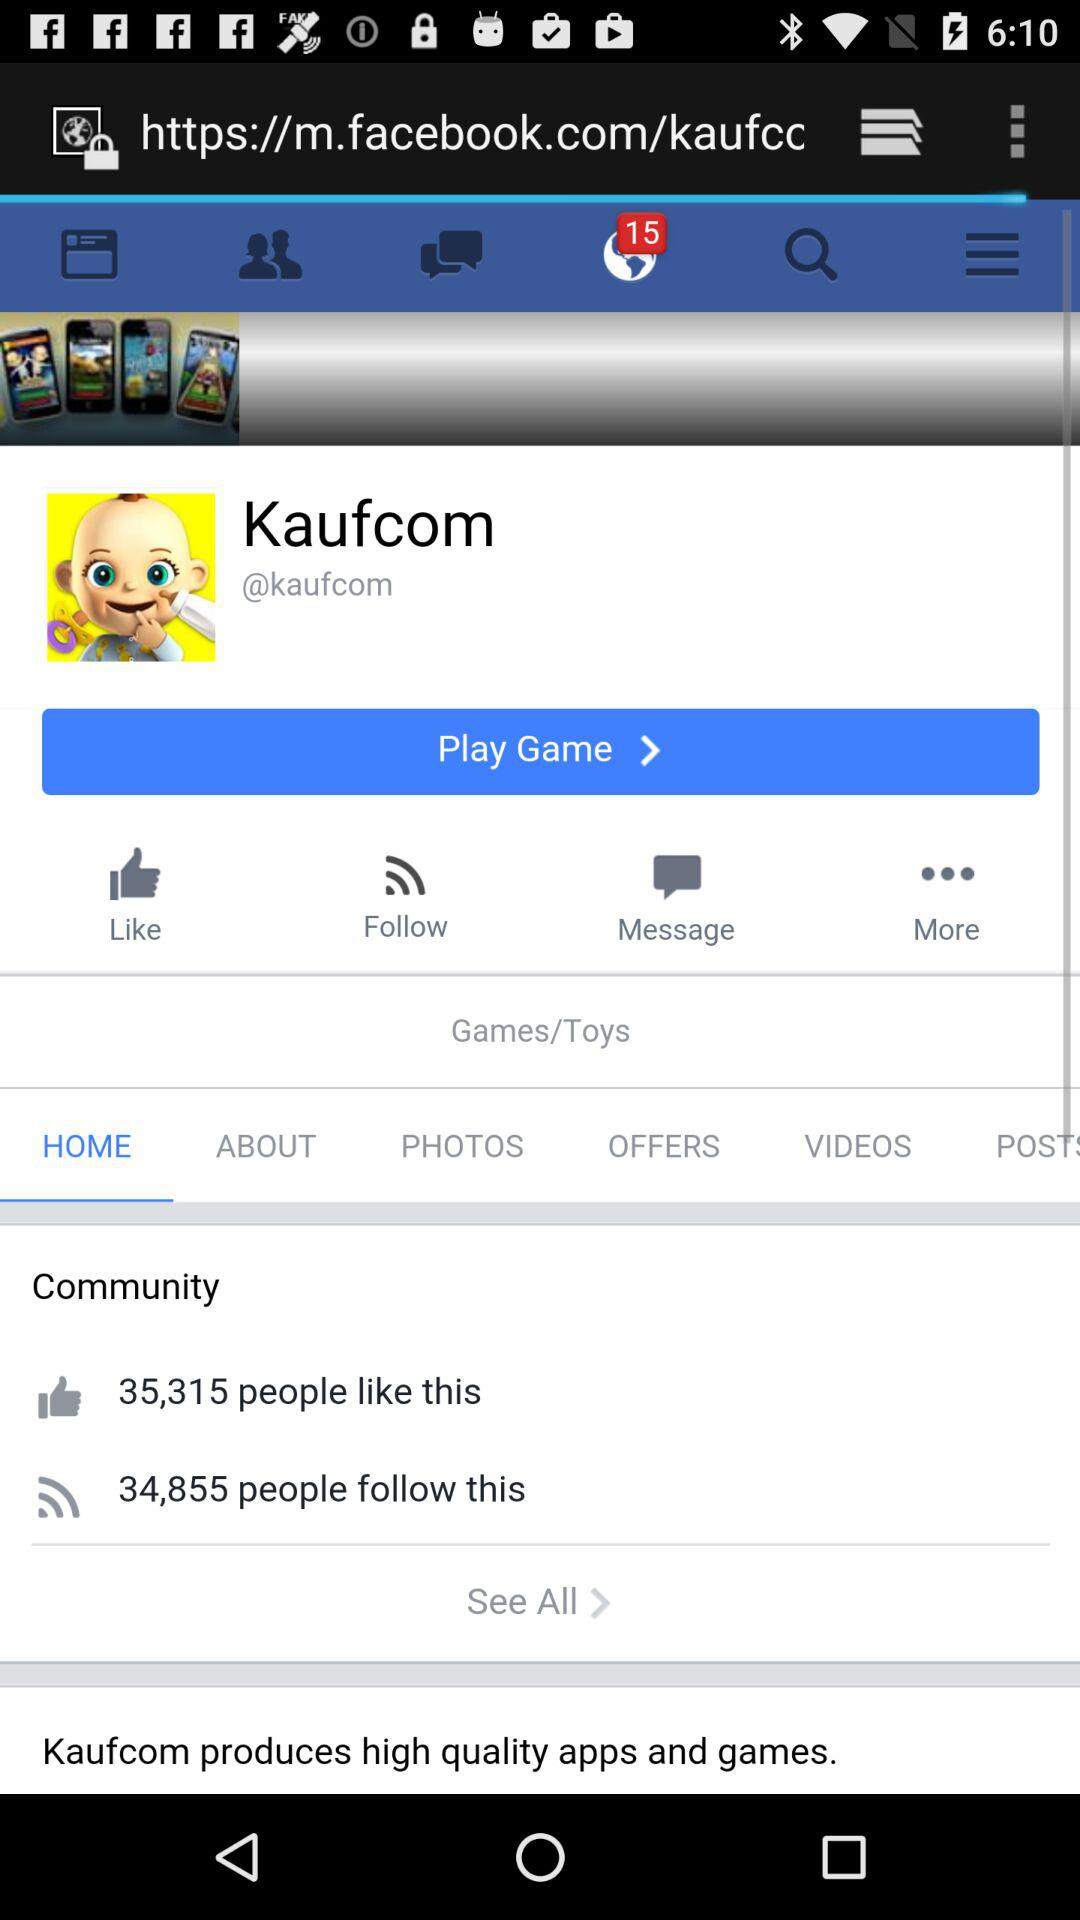Which option is selected? The selected options are "Notification" and "Home". 